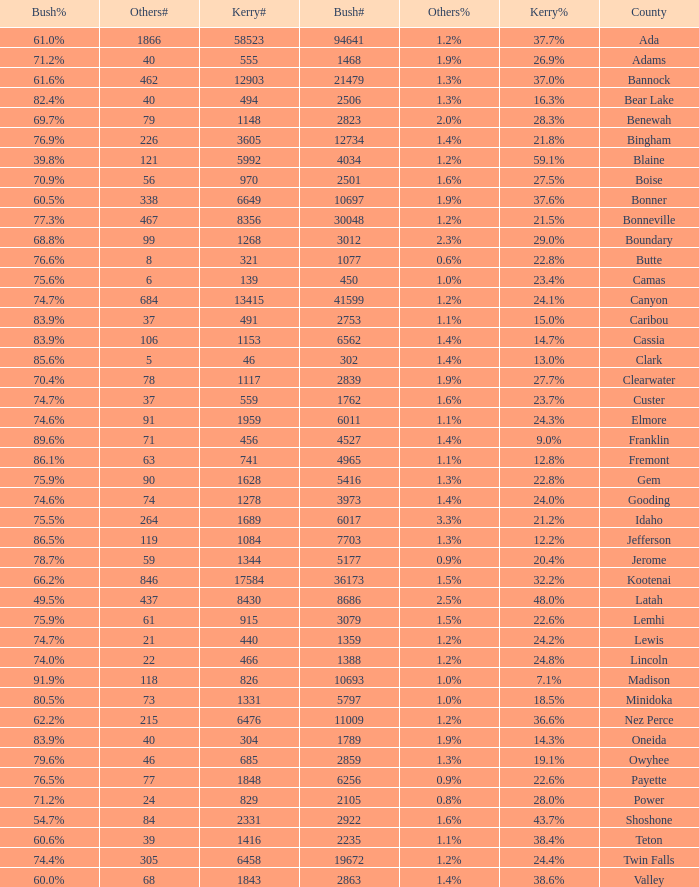How many different counts of the votes for Bush are there in the county where he got 69.7% of the votes? 1.0. 